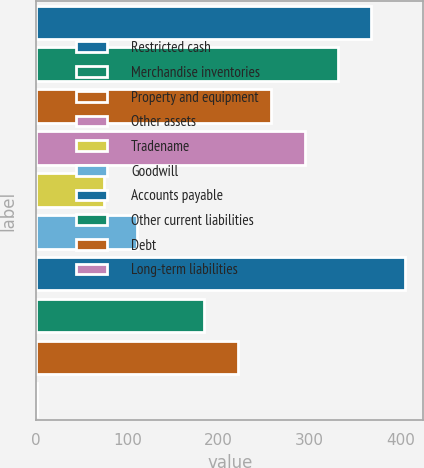<chart> <loc_0><loc_0><loc_500><loc_500><bar_chart><fcel>Restricted cash<fcel>Merchandise inventories<fcel>Property and equipment<fcel>Other assets<fcel>Tradename<fcel>Goodwill<fcel>Accounts payable<fcel>Other current liabilities<fcel>Debt<fcel>Long-term liabilities<nl><fcel>368<fcel>331.3<fcel>257.9<fcel>294.6<fcel>74.4<fcel>111.1<fcel>404.7<fcel>184.5<fcel>221.2<fcel>1<nl></chart> 